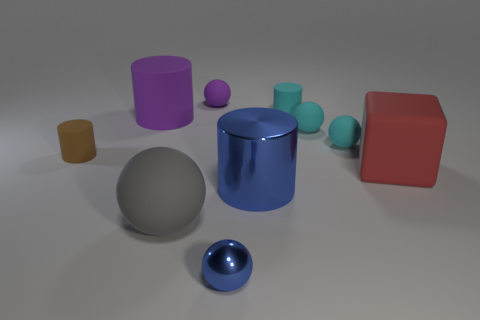What number of yellow objects are either big rubber objects or matte cylinders?
Offer a terse response. 0. What number of shiny things are the same color as the tiny metal ball?
Your answer should be very brief. 1. Is there any other thing that has the same shape as the red thing?
Ensure brevity in your answer.  No. What number of cylinders are either purple objects or big blue things?
Offer a very short reply. 2. There is a cylinder that is to the right of the shiny cylinder; what color is it?
Keep it short and to the point. Cyan. What shape is the red matte object that is the same size as the gray matte ball?
Your response must be concise. Cube. What number of red blocks are left of the blue ball?
Make the answer very short. 0. What number of things are either purple rubber objects or purple matte spheres?
Keep it short and to the point. 2. The large object that is on the left side of the large blue cylinder and in front of the red rubber thing has what shape?
Your answer should be compact. Sphere. How many large blue cylinders are there?
Make the answer very short. 1. 